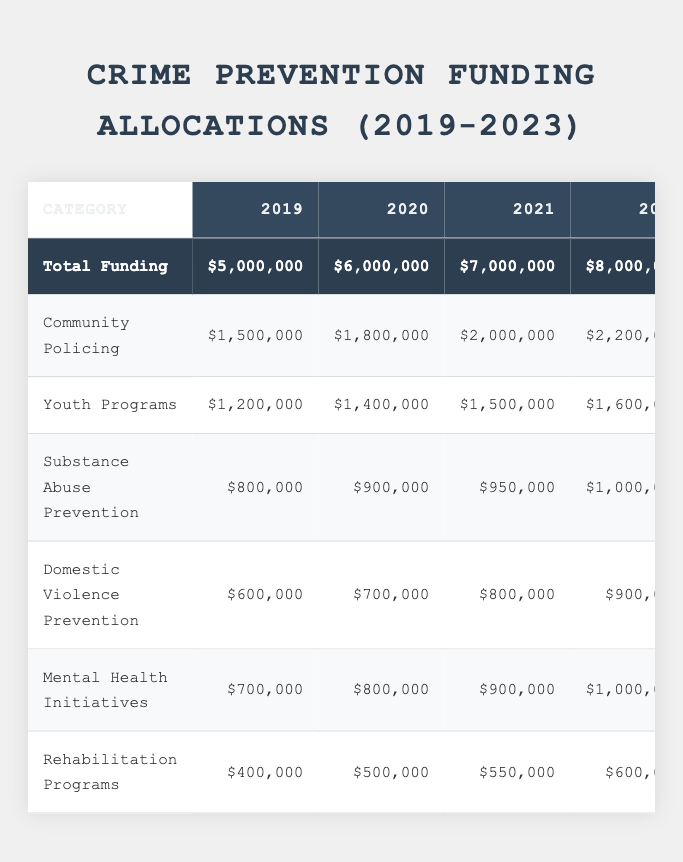What was the total funding allocated in 2022? The table shows that the total funding for the year 2022 is listed as $8,000,000.
Answer: $8,000,000 Which category received the highest funding in 2021? According to the table, Community Policing received the highest funding in 2021, which is $2,000,000.
Answer: Community Policing How much more funding was allocated to Domestic Violence Prevention in 2023 compared to 2019? In 2023, the funding for Domestic Violence Prevention was $1,000,000, while in 2019 it was $600,000. The difference is $1,000,000 - $600,000 = $400,000.
Answer: $400,000 What is the average funding for Rehabilitation Programs from 2019 to 2023? To find the average, we add the funding amounts: $400,000 + $500,000 + $550,000 + $600,000 + $700,000 = $2,750,000. Then we divide by 5 (the number of years), resulting in an average of $2,750,000 / 5 = $550,000.
Answer: $550,000 Did the funding for Substance Abuse Prevention increase every year from 2019 to 2023? By examining the table, the funding for Substance Abuse Prevention was $800,000 in 2019 and increased every year to $1,100,000 in 2023, confirming the increase for each year.
Answer: Yes What year had the total funding that was least compared to the total funding of 2023? The total funding for 2023 is $9,000,000. The year with the least total funding was 2019, which had $5,000,000. The difference shows 2019 had the least compared to 2023.
Answer: 2019 What percentage of the total funding in 2022 was allocated to Youth Programs? The total funding for 2022 is $8,000,000, and the funding for Youth Programs is $1,600,000. The percentage is calculated as ($1,600,000 / $8,000,000) * 100 = 20%.
Answer: 20% Was the increase in total funding from 2020 to 2021 greater than the increase from 2021 to 2022? The increase from 2020 to 2021 was $7,000,000 - $6,000,000 = $1,000,000, while the increase from 2021 to 2022 was $8,000,000 - $7,000,000 = $1,000,000. Both increases are equal.
Answer: No Which category saw the smallest increase in funding from 2022 to 2023? From the table, the funding for Rehabilitation Programs increased from $600,000 in 2022 to $700,000 in 2023, showing a $100,000 increase, which is smaller than the increases in all other categories.
Answer: Rehabilitation Programs If the trend continues, what would be the projected total funding for 2024? The total funding has increased by $1,000,000 each year from 2019 to 2023. Therefore, it can be projected that the 2024 total funding would be $9,000,000 + $1,000,000 = $10,000,000.
Answer: $10,000,000 